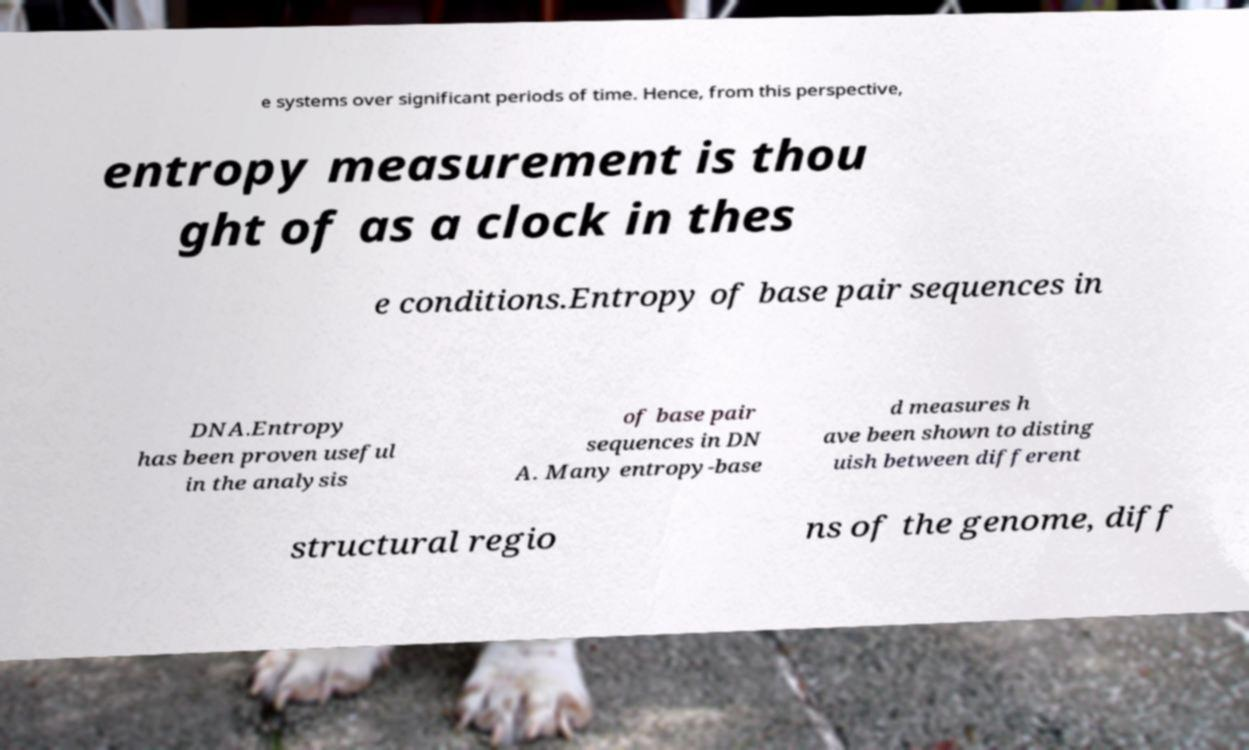Please identify and transcribe the text found in this image. e systems over significant periods of time. Hence, from this perspective, entropy measurement is thou ght of as a clock in thes e conditions.Entropy of base pair sequences in DNA.Entropy has been proven useful in the analysis of base pair sequences in DN A. Many entropy-base d measures h ave been shown to disting uish between different structural regio ns of the genome, diff 